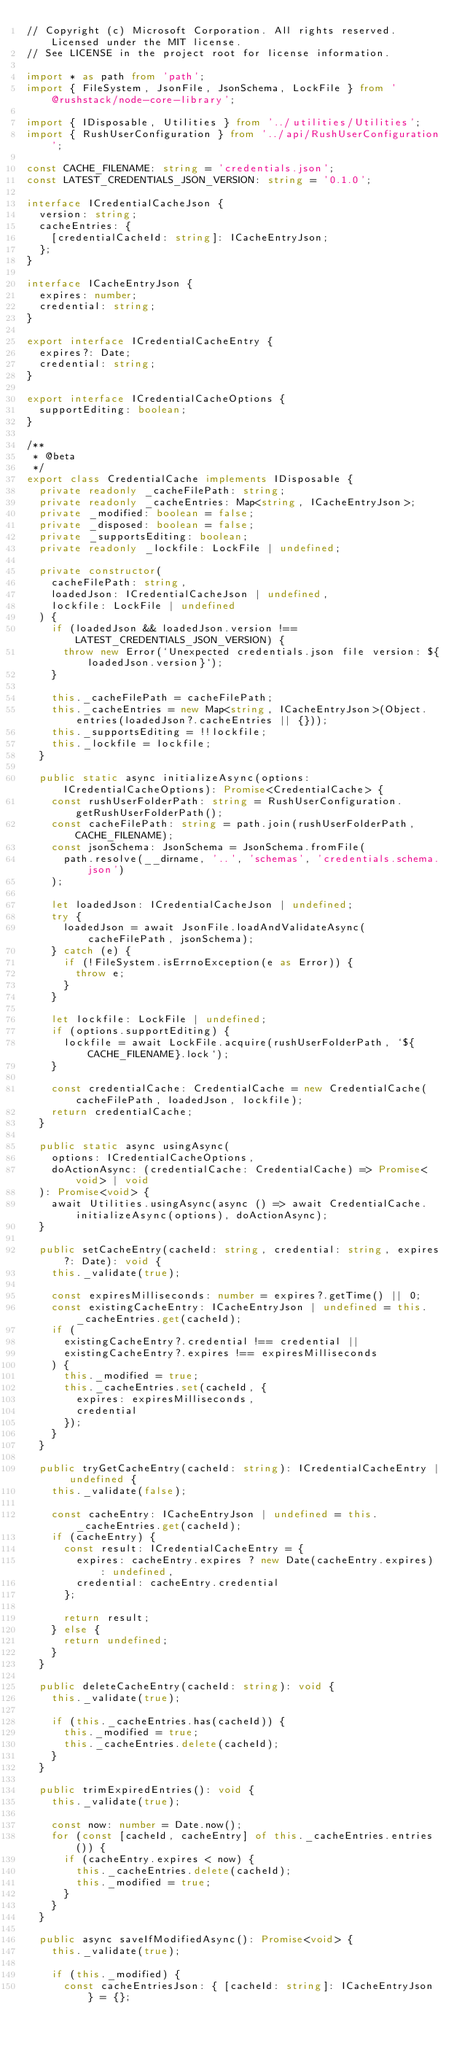<code> <loc_0><loc_0><loc_500><loc_500><_TypeScript_>// Copyright (c) Microsoft Corporation. All rights reserved. Licensed under the MIT license.
// See LICENSE in the project root for license information.

import * as path from 'path';
import { FileSystem, JsonFile, JsonSchema, LockFile } from '@rushstack/node-core-library';

import { IDisposable, Utilities } from '../utilities/Utilities';
import { RushUserConfiguration } from '../api/RushUserConfiguration';

const CACHE_FILENAME: string = 'credentials.json';
const LATEST_CREDENTIALS_JSON_VERSION: string = '0.1.0';

interface ICredentialCacheJson {
  version: string;
  cacheEntries: {
    [credentialCacheId: string]: ICacheEntryJson;
  };
}

interface ICacheEntryJson {
  expires: number;
  credential: string;
}

export interface ICredentialCacheEntry {
  expires?: Date;
  credential: string;
}

export interface ICredentialCacheOptions {
  supportEditing: boolean;
}

/**
 * @beta
 */
export class CredentialCache implements IDisposable {
  private readonly _cacheFilePath: string;
  private readonly _cacheEntries: Map<string, ICacheEntryJson>;
  private _modified: boolean = false;
  private _disposed: boolean = false;
  private _supportsEditing: boolean;
  private readonly _lockfile: LockFile | undefined;

  private constructor(
    cacheFilePath: string,
    loadedJson: ICredentialCacheJson | undefined,
    lockfile: LockFile | undefined
  ) {
    if (loadedJson && loadedJson.version !== LATEST_CREDENTIALS_JSON_VERSION) {
      throw new Error(`Unexpected credentials.json file version: ${loadedJson.version}`);
    }

    this._cacheFilePath = cacheFilePath;
    this._cacheEntries = new Map<string, ICacheEntryJson>(Object.entries(loadedJson?.cacheEntries || {}));
    this._supportsEditing = !!lockfile;
    this._lockfile = lockfile;
  }

  public static async initializeAsync(options: ICredentialCacheOptions): Promise<CredentialCache> {
    const rushUserFolderPath: string = RushUserConfiguration.getRushUserFolderPath();
    const cacheFilePath: string = path.join(rushUserFolderPath, CACHE_FILENAME);
    const jsonSchema: JsonSchema = JsonSchema.fromFile(
      path.resolve(__dirname, '..', 'schemas', 'credentials.schema.json')
    );

    let loadedJson: ICredentialCacheJson | undefined;
    try {
      loadedJson = await JsonFile.loadAndValidateAsync(cacheFilePath, jsonSchema);
    } catch (e) {
      if (!FileSystem.isErrnoException(e as Error)) {
        throw e;
      }
    }

    let lockfile: LockFile | undefined;
    if (options.supportEditing) {
      lockfile = await LockFile.acquire(rushUserFolderPath, `${CACHE_FILENAME}.lock`);
    }

    const credentialCache: CredentialCache = new CredentialCache(cacheFilePath, loadedJson, lockfile);
    return credentialCache;
  }

  public static async usingAsync(
    options: ICredentialCacheOptions,
    doActionAsync: (credentialCache: CredentialCache) => Promise<void> | void
  ): Promise<void> {
    await Utilities.usingAsync(async () => await CredentialCache.initializeAsync(options), doActionAsync);
  }

  public setCacheEntry(cacheId: string, credential: string, expires?: Date): void {
    this._validate(true);

    const expiresMilliseconds: number = expires?.getTime() || 0;
    const existingCacheEntry: ICacheEntryJson | undefined = this._cacheEntries.get(cacheId);
    if (
      existingCacheEntry?.credential !== credential ||
      existingCacheEntry?.expires !== expiresMilliseconds
    ) {
      this._modified = true;
      this._cacheEntries.set(cacheId, {
        expires: expiresMilliseconds,
        credential
      });
    }
  }

  public tryGetCacheEntry(cacheId: string): ICredentialCacheEntry | undefined {
    this._validate(false);

    const cacheEntry: ICacheEntryJson | undefined = this._cacheEntries.get(cacheId);
    if (cacheEntry) {
      const result: ICredentialCacheEntry = {
        expires: cacheEntry.expires ? new Date(cacheEntry.expires) : undefined,
        credential: cacheEntry.credential
      };

      return result;
    } else {
      return undefined;
    }
  }

  public deleteCacheEntry(cacheId: string): void {
    this._validate(true);

    if (this._cacheEntries.has(cacheId)) {
      this._modified = true;
      this._cacheEntries.delete(cacheId);
    }
  }

  public trimExpiredEntries(): void {
    this._validate(true);

    const now: number = Date.now();
    for (const [cacheId, cacheEntry] of this._cacheEntries.entries()) {
      if (cacheEntry.expires < now) {
        this._cacheEntries.delete(cacheId);
        this._modified = true;
      }
    }
  }

  public async saveIfModifiedAsync(): Promise<void> {
    this._validate(true);

    if (this._modified) {
      const cacheEntriesJson: { [cacheId: string]: ICacheEntryJson } = {};</code> 